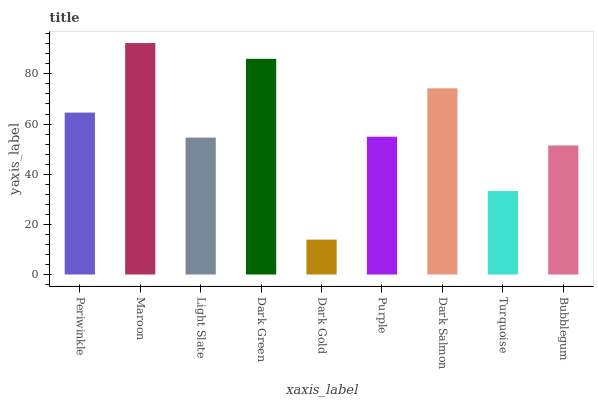Is Dark Gold the minimum?
Answer yes or no. Yes. Is Maroon the maximum?
Answer yes or no. Yes. Is Light Slate the minimum?
Answer yes or no. No. Is Light Slate the maximum?
Answer yes or no. No. Is Maroon greater than Light Slate?
Answer yes or no. Yes. Is Light Slate less than Maroon?
Answer yes or no. Yes. Is Light Slate greater than Maroon?
Answer yes or no. No. Is Maroon less than Light Slate?
Answer yes or no. No. Is Purple the high median?
Answer yes or no. Yes. Is Purple the low median?
Answer yes or no. Yes. Is Dark Salmon the high median?
Answer yes or no. No. Is Periwinkle the low median?
Answer yes or no. No. 